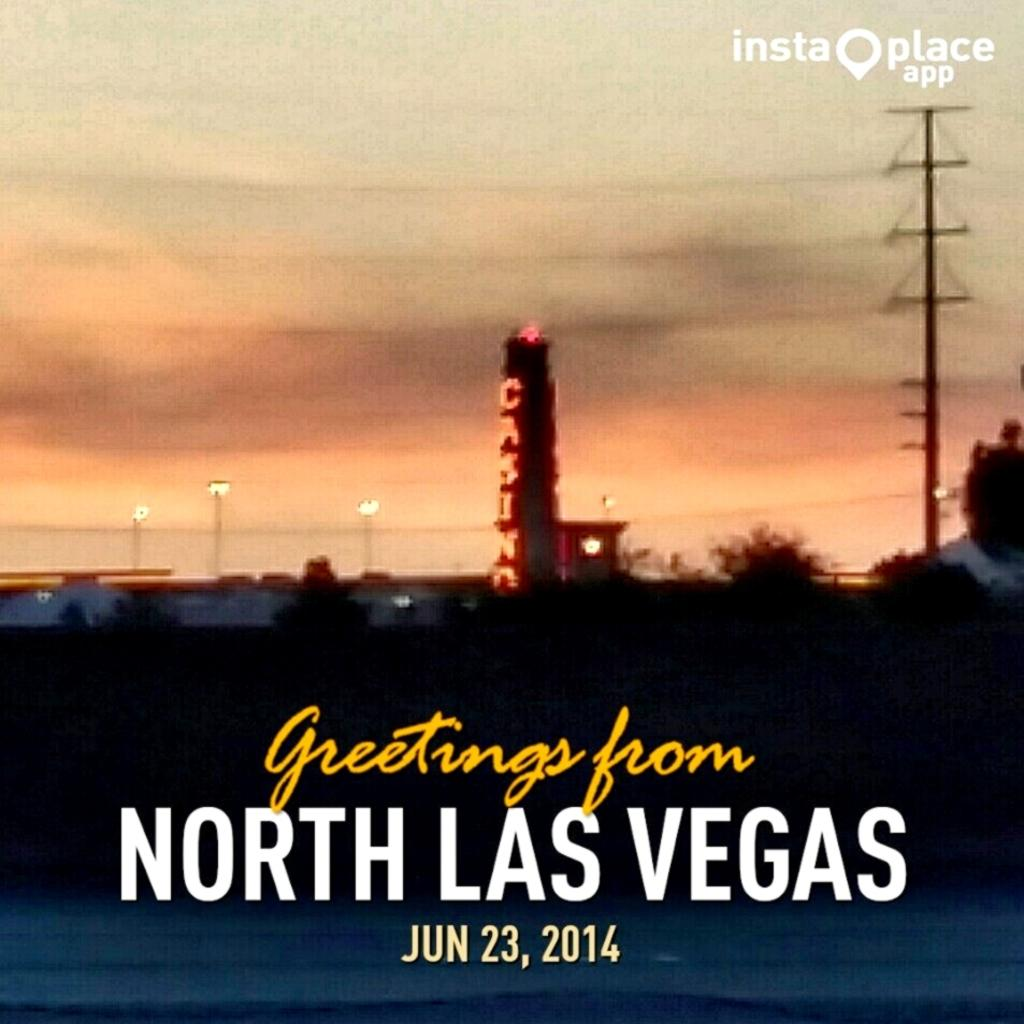<image>
Describe the image concisely. Postcard that was taken on June 23rd and says "Greetings from North Las Vegas". 